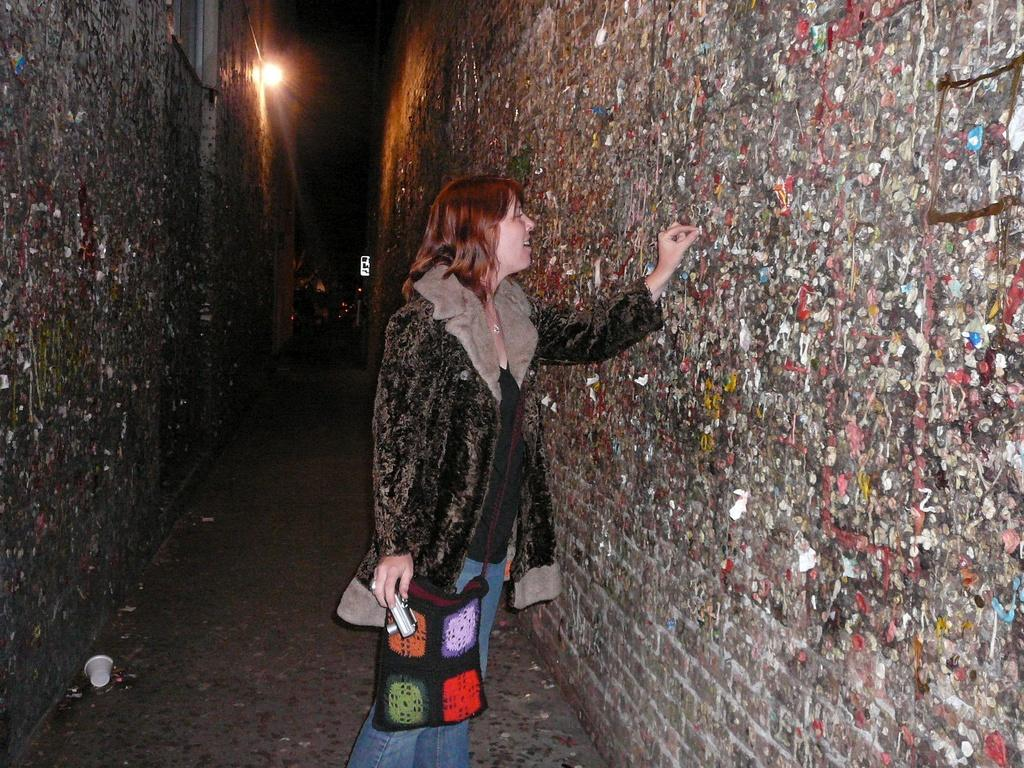Who is present in the image? There is a woman in the image. What is the woman holding? The woman is holding a camera. What is in front of the woman? There is a wall in front of the woman. What can be seen in the background of the image? There is a light visible in the background of the image. How many tomatoes are on the wall in the image? There are no tomatoes present in the image; the wall is the only object mentioned in the facts. 